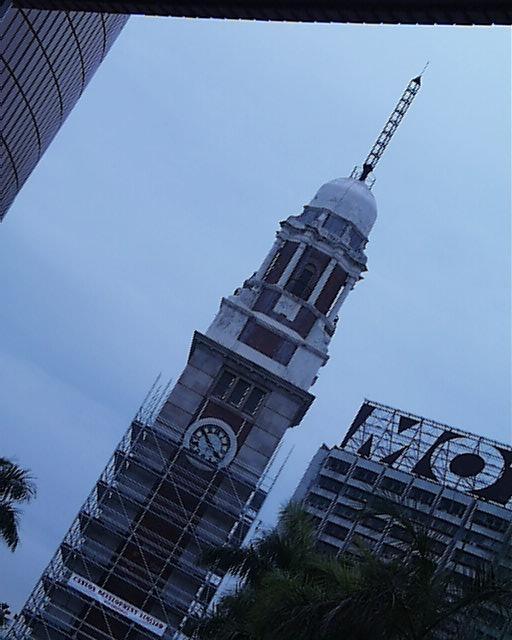What color is the top of the statue?
Be succinct. White. Are there palm trees in the picture?
Answer briefly. Yes. How was the picture taken?
Quick response, please. With camera. Does the scaffolding cover the entire building?
Be succinct. No. 